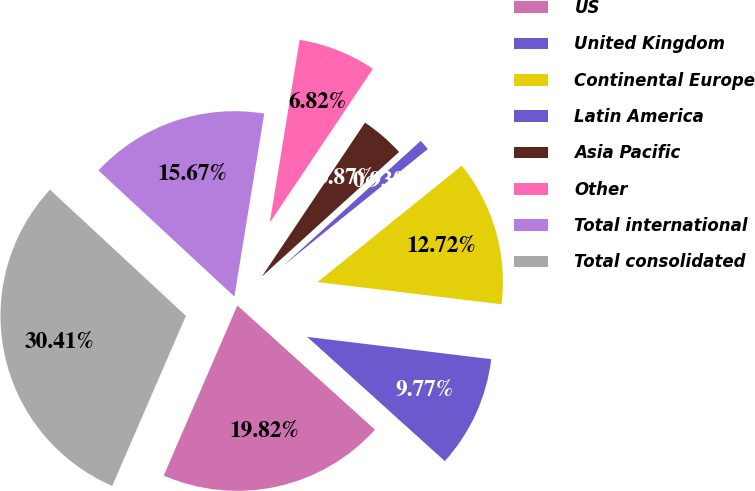Convert chart to OTSL. <chart><loc_0><loc_0><loc_500><loc_500><pie_chart><fcel>US<fcel>United Kingdom<fcel>Continental Europe<fcel>Latin America<fcel>Asia Pacific<fcel>Other<fcel>Total international<fcel>Total consolidated<nl><fcel>19.82%<fcel>9.77%<fcel>12.72%<fcel>0.93%<fcel>3.87%<fcel>6.82%<fcel>15.67%<fcel>30.41%<nl></chart> 